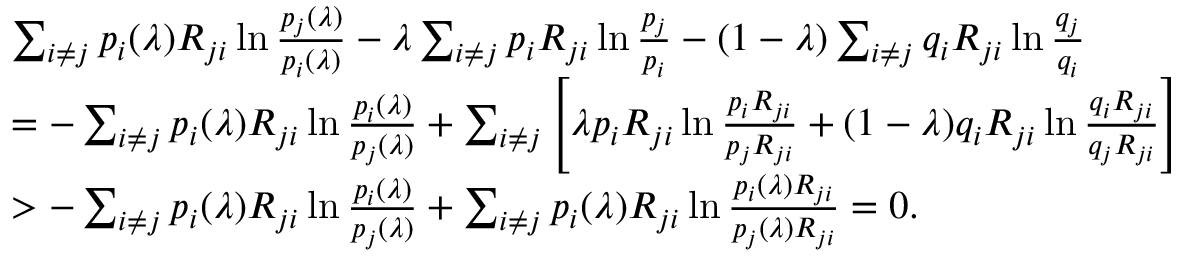<formula> <loc_0><loc_0><loc_500><loc_500>\begin{array} { r l } & { \sum _ { i \ne j } p _ { i } ( \lambda ) R _ { j i } \ln \frac { p _ { j } ( \lambda ) } { p _ { i } ( \lambda ) } - \lambda \sum _ { i \ne j } p _ { i } R _ { j i } \ln \frac { p _ { j } } { p _ { i } } - ( 1 - \lambda ) \sum _ { i \ne j } q _ { i } R _ { j i } \ln \frac { q _ { j } } { q _ { i } } } \\ & { = - \sum _ { i \ne j } p _ { i } ( \lambda ) R _ { j i } \ln \frac { p _ { i } ( \lambda ) } { p _ { j } ( \lambda ) } + \sum _ { i \ne j } \left [ \lambda p _ { i } R _ { j i } \ln \frac { p _ { i } R _ { j i } } { p _ { j } R _ { j i } } + ( 1 - \lambda ) q _ { i } R _ { j i } \ln \frac { q _ { i } R _ { j i } } { q _ { j } R _ { j i } } \right ] } \\ & { > - \sum _ { i \ne j } p _ { i } ( \lambda ) R _ { j i } \ln \frac { p _ { i } ( \lambda ) } { p _ { j } ( \lambda ) } + \sum _ { i \ne j } p _ { i } ( \lambda ) R _ { j i } \ln \frac { p _ { i } ( \lambda ) R _ { j i } } { p _ { j } ( \lambda ) R _ { j i } } = 0 . } \end{array}</formula> 